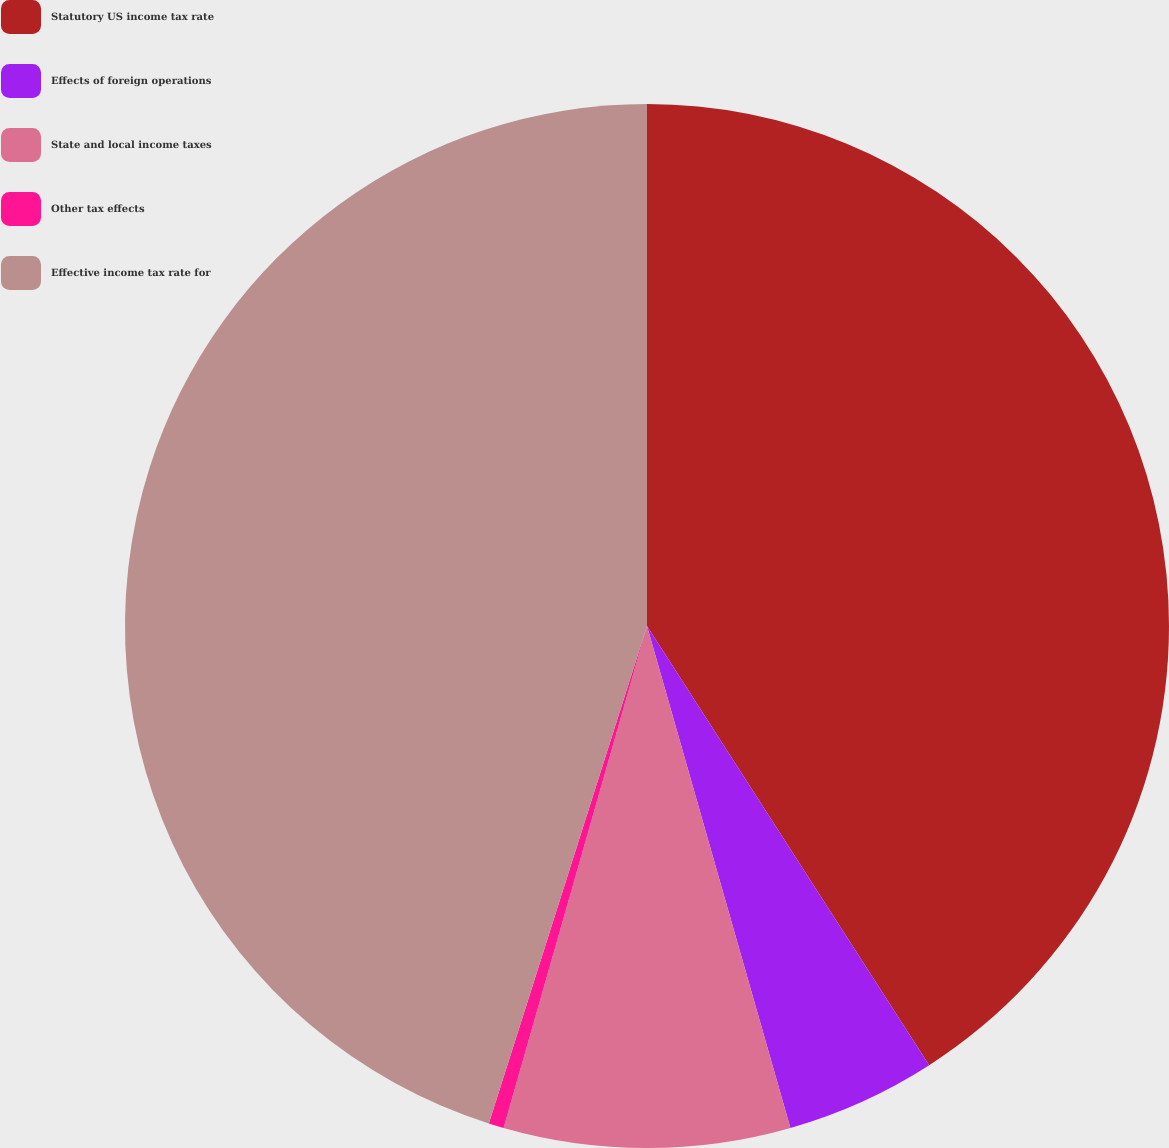Convert chart. <chart><loc_0><loc_0><loc_500><loc_500><pie_chart><fcel>Statutory US income tax rate<fcel>Effects of foreign operations<fcel>State and local income taxes<fcel>Other tax effects<fcel>Effective income tax rate for<nl><fcel>40.91%<fcel>4.66%<fcel>8.86%<fcel>0.47%<fcel>45.1%<nl></chart> 